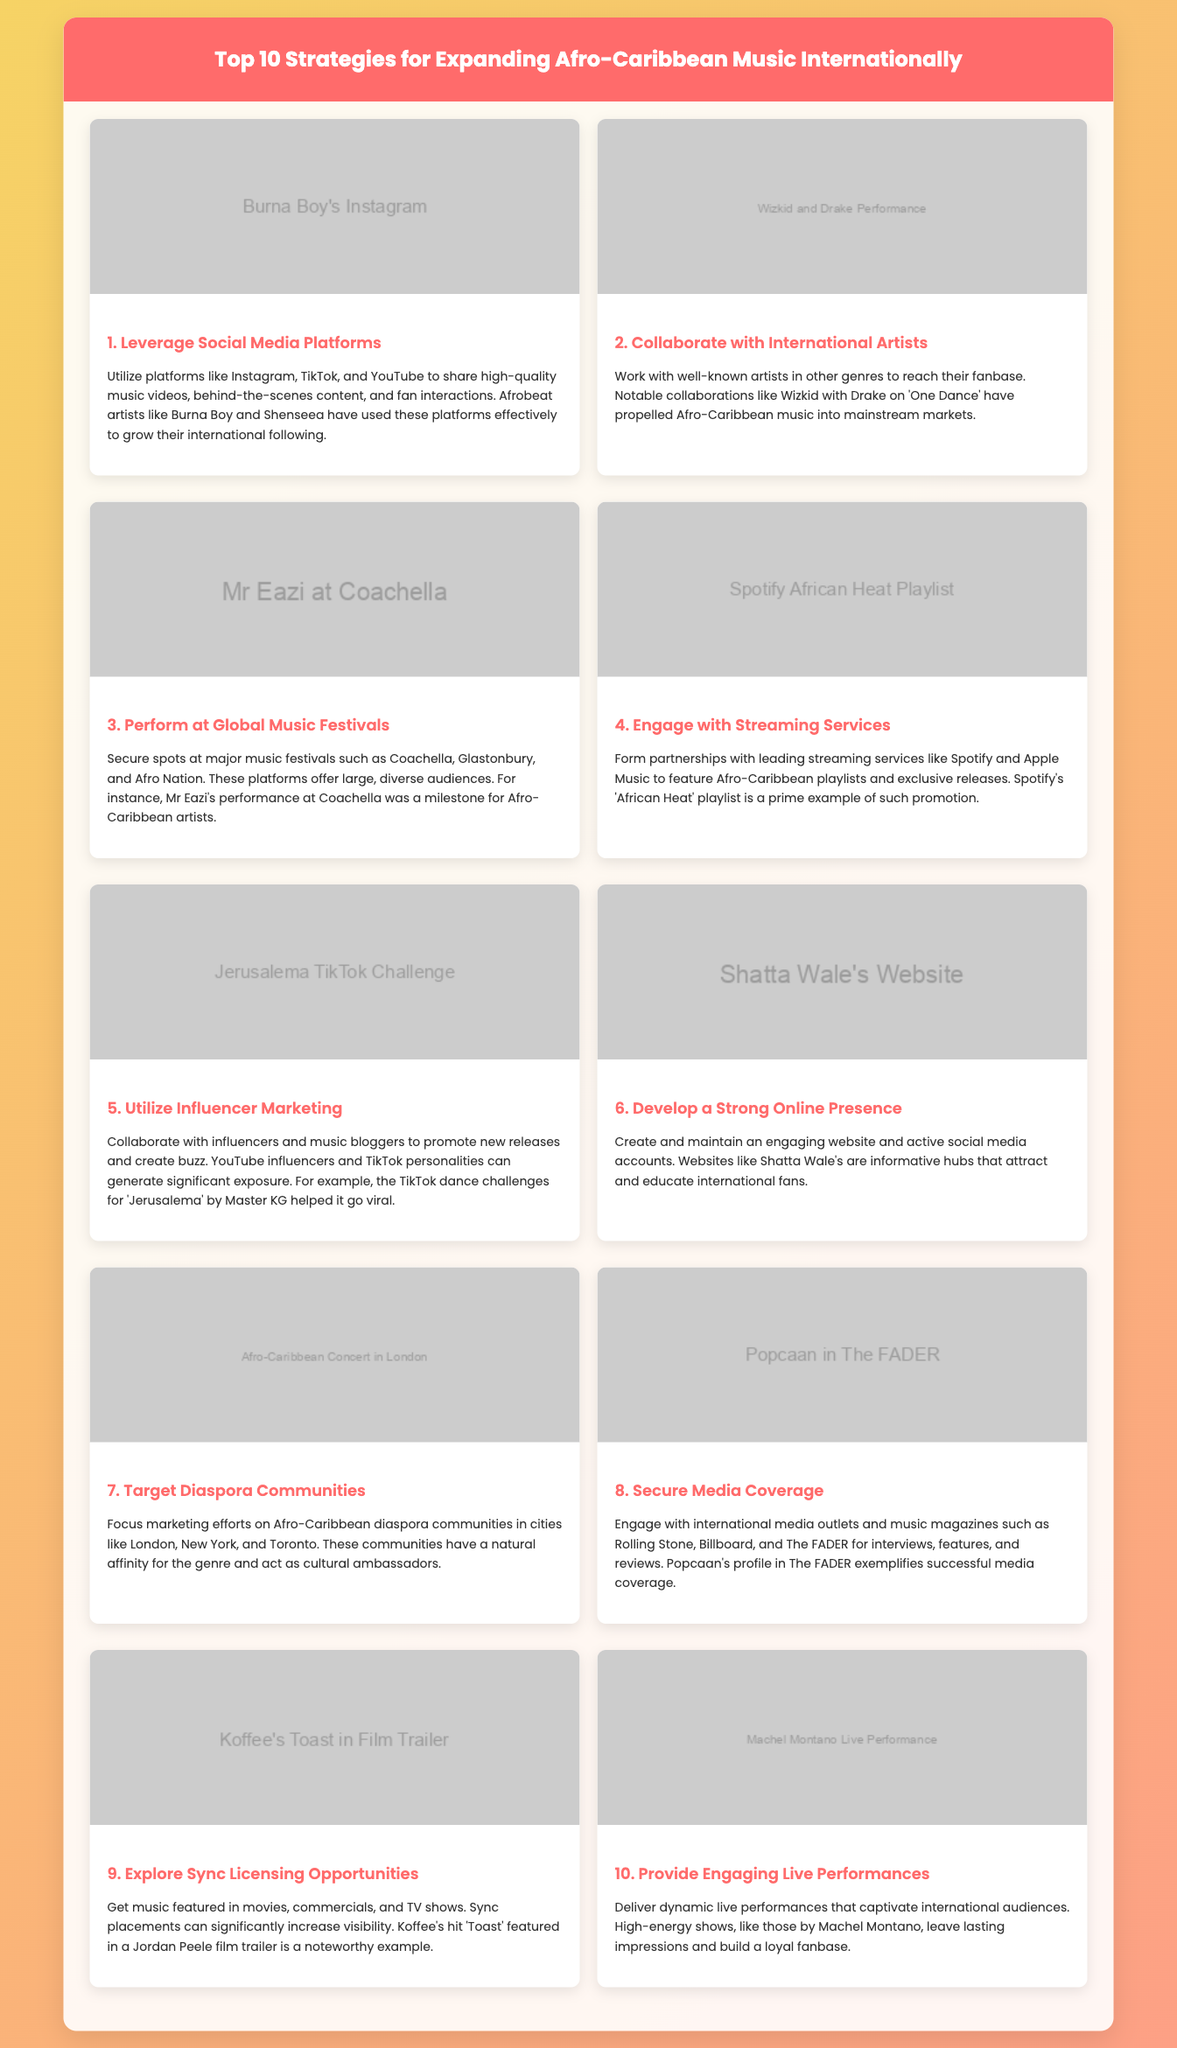What is the first strategy for expanding Afro-Caribbean music internationally? The first strategy mentioned in the document is leveraging social media platforms.
Answer: Leverage Social Media Platforms Who collaborated with Wizkid in the song 'One Dance'? The document states Wizkid collaborated with Drake for the song 'One Dance'.
Answer: Drake What event did Mr Eazi perform at that marked a milestone for Afro-Caribbean artists? The document highlights Mr Eazi's performance at Coachella as a significant milestone.
Answer: Coachella Which playlist on Spotify is mentioned as a promotional example for Afro-Caribbean music? The document refers to Spotify's 'African Heat' playlist as a prime example for promotion.
Answer: African Heat What is a notable example of utilizing influencer marketing mentioned in the document? The document discusses the TikTok dance challenges for ‘Jerusalema’ by Master KG as a significant example.
Answer: Jerusalema TikTok Challenge Which communities should be targeted according to the strategies? The document suggests targeting Afro-Caribbean diaspora communities in cities like London, New York, and Toronto.
Answer: Diaspora Communities Which publication featured Popcaan that exemplifies successful media coverage? The document indicates Popcaan's profile in The FADER as an example of successful media coverage.
Answer: The FADER What type of opportunities should Afro-Caribbean artists explore according to strategy nine? The document mentions exploring sync licensing opportunities as a strategy for increased visibility.
Answer: Sync Licensing What type of performances should be delivered to captivate international audiences? The document emphasizes providing engaging live performances to captivate audiences.
Answer: Engaging Live Performances 